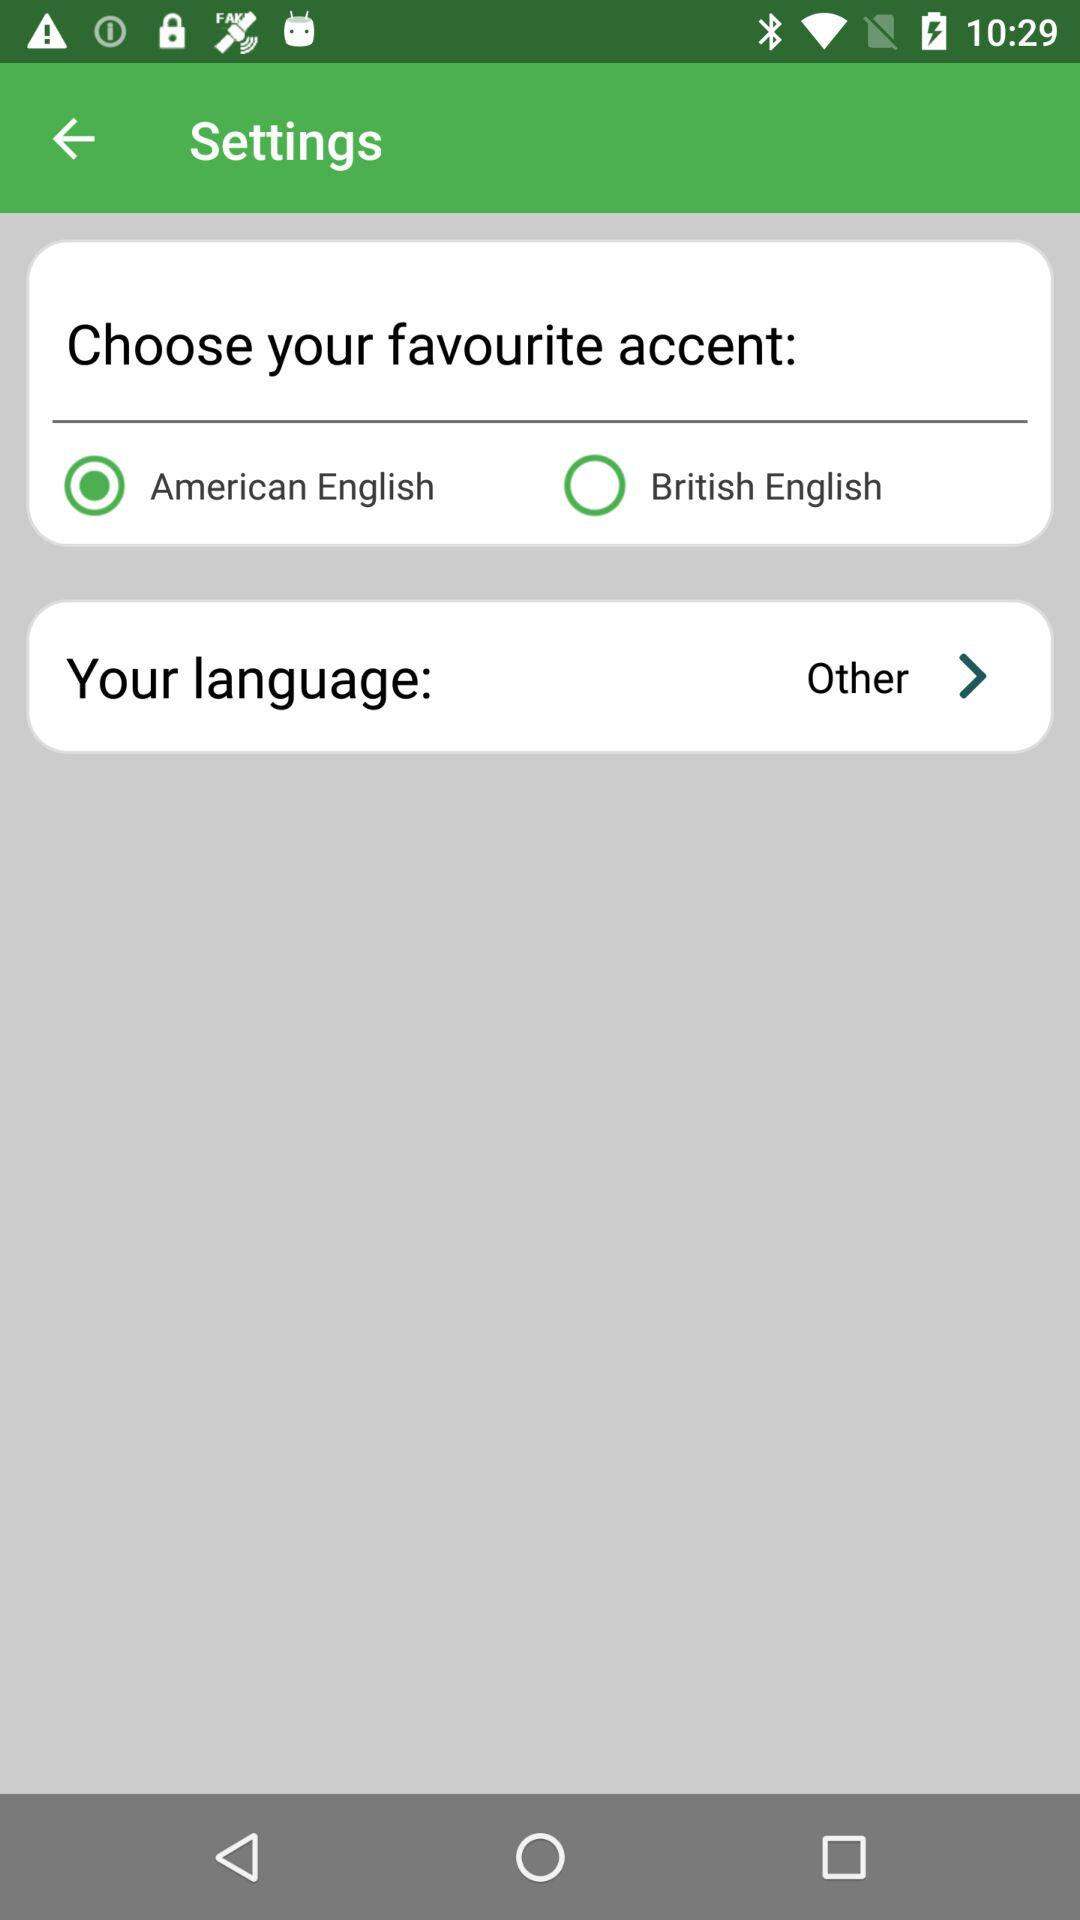What language is selected? The selected language is "Other". 